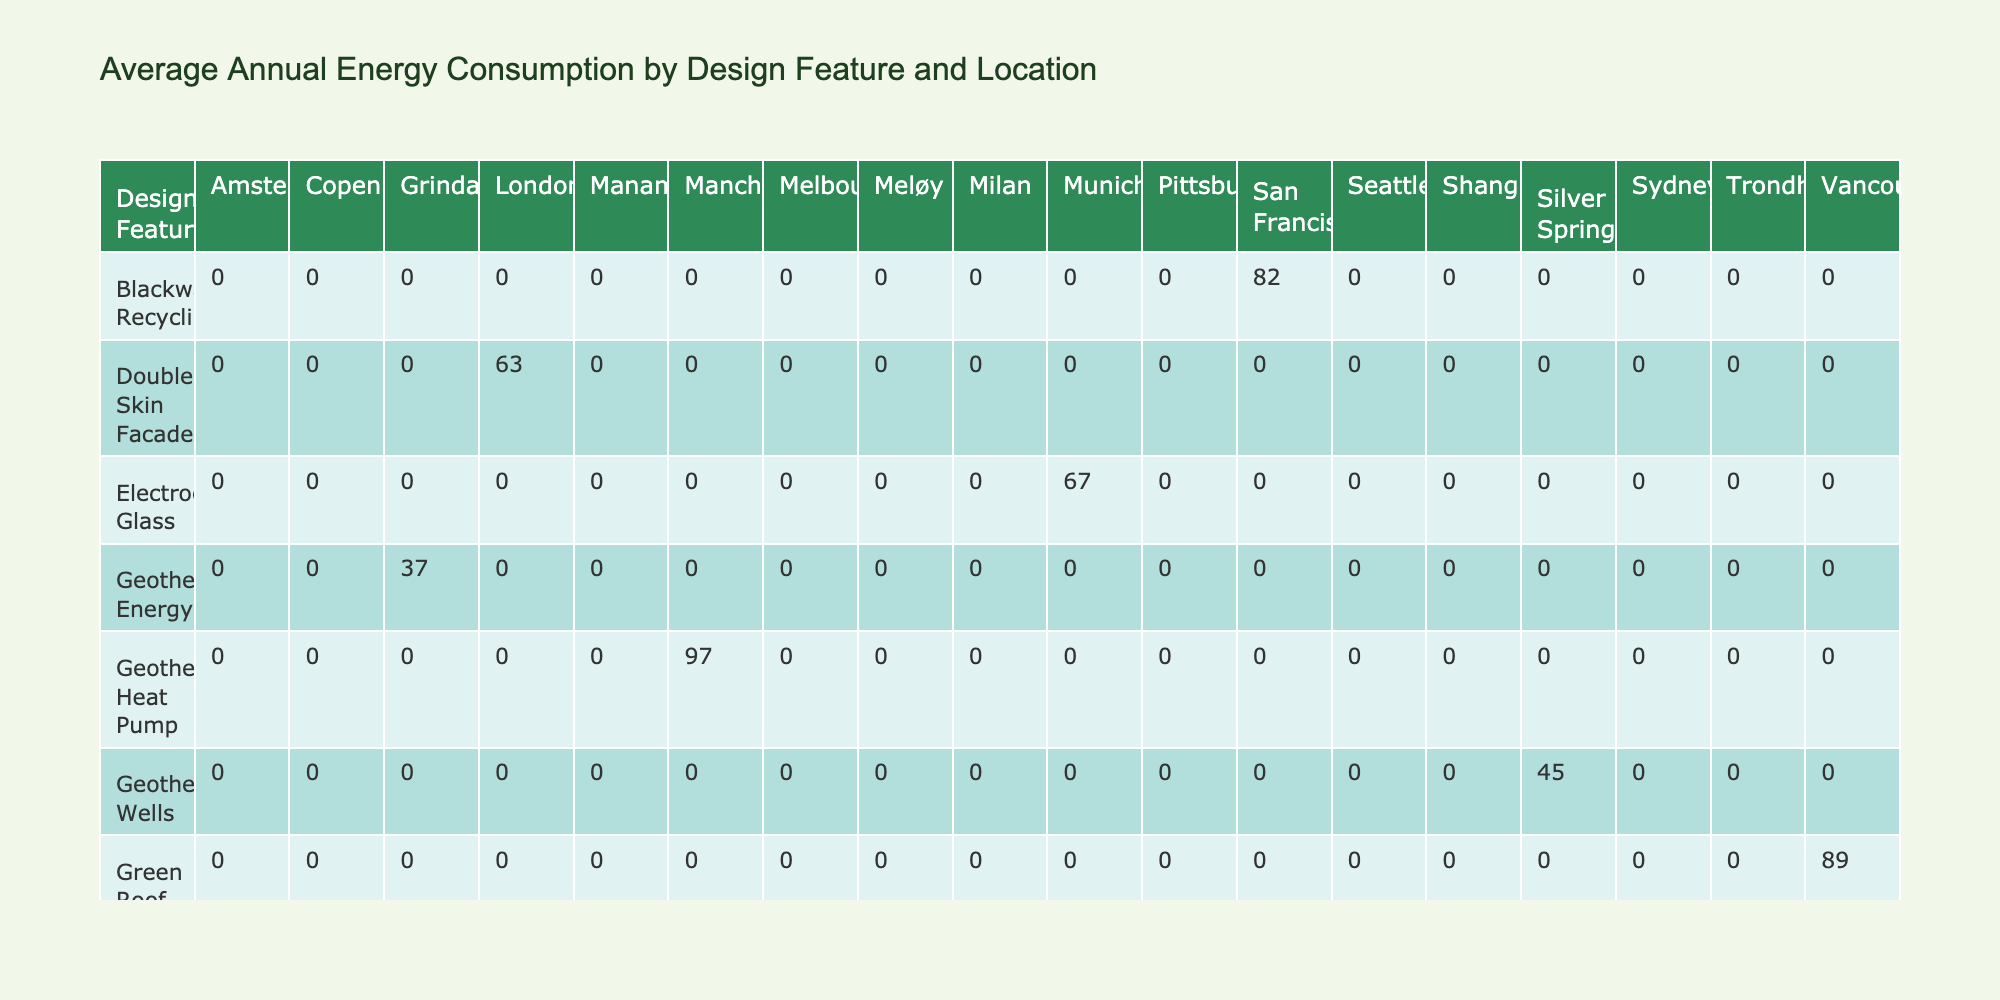What is the average annual energy consumption for buildings with Solar Panels? In the table, we find the buildings with Solar Panels: Bullitt Center (12), Svart Hotel (8), and The Tower at PNC Plaza (76). To calculate the average, we sum these values: 12 + 8 + 76 = 96. Then we divide by the number of buildings which is 3: 96 / 3 = 32.
Answer: 32 Which location has the highest annual energy consumption for eco-friendly buildings? We can compare the values in the table for each location. The highest value is in Manama (Bahrain World Trade Center) with 104 kWh/m²/year.
Answer: Manama Do buildings using Wind Turbines have lower energy consumption than those with Geothermal Heat Pumps? For buildings with Wind Turbines, we have Bahrain World Trade Center (104) and Shanghai Tower (93), giving an average of (104 + 93) / 2 = 98.5. For Geothermal Heat Pumps, we have One Angel Square (97) which is the only building in that category. Since 98.5 > 97, the statement is false.
Answer: No What is the total annual energy consumption for locations with Vertical Gardens? The only building with Vertical Gardens is One Central Park (69). Thus, the total consumption is 69.
Answer: 69 Is the CO2 emission more than 10 kg/m²/year for buildings in London? In the table, buildings in London are The Crystal (12.6) and Bloomberg London (11.2). Both values exceed 10 kg/m²/year, confirming that the statement is true.
Answer: Yes What is the difference in annual energy consumption between the building with the highest and the lowest consumption? The building with the highest consumption is Bahrain World Trade Center (104) and the lowest is Svart Hotel (8). The difference is 104 - 8 = 96.
Answer: 96 Which design feature has the lowest average annual energy consumption? We summarize all the design features: Solar Panels average 32, Smart Lighting is 41, Geothermal Heat Pump is 97, etc. The lowest average from these calculations is Solar Panels with an average of 32 kWh/m²/year.
Answer: Solar Panels What design feature contributes to the highest CO2 emissions among the buildings? By inspecting the CO2 emissions in the table, we find Bahrain World Trade Center contributing 20.8 kg/m²/year due to its Wind Turbines. This is greater than any other design feature listed.
Answer: Wind Turbines 